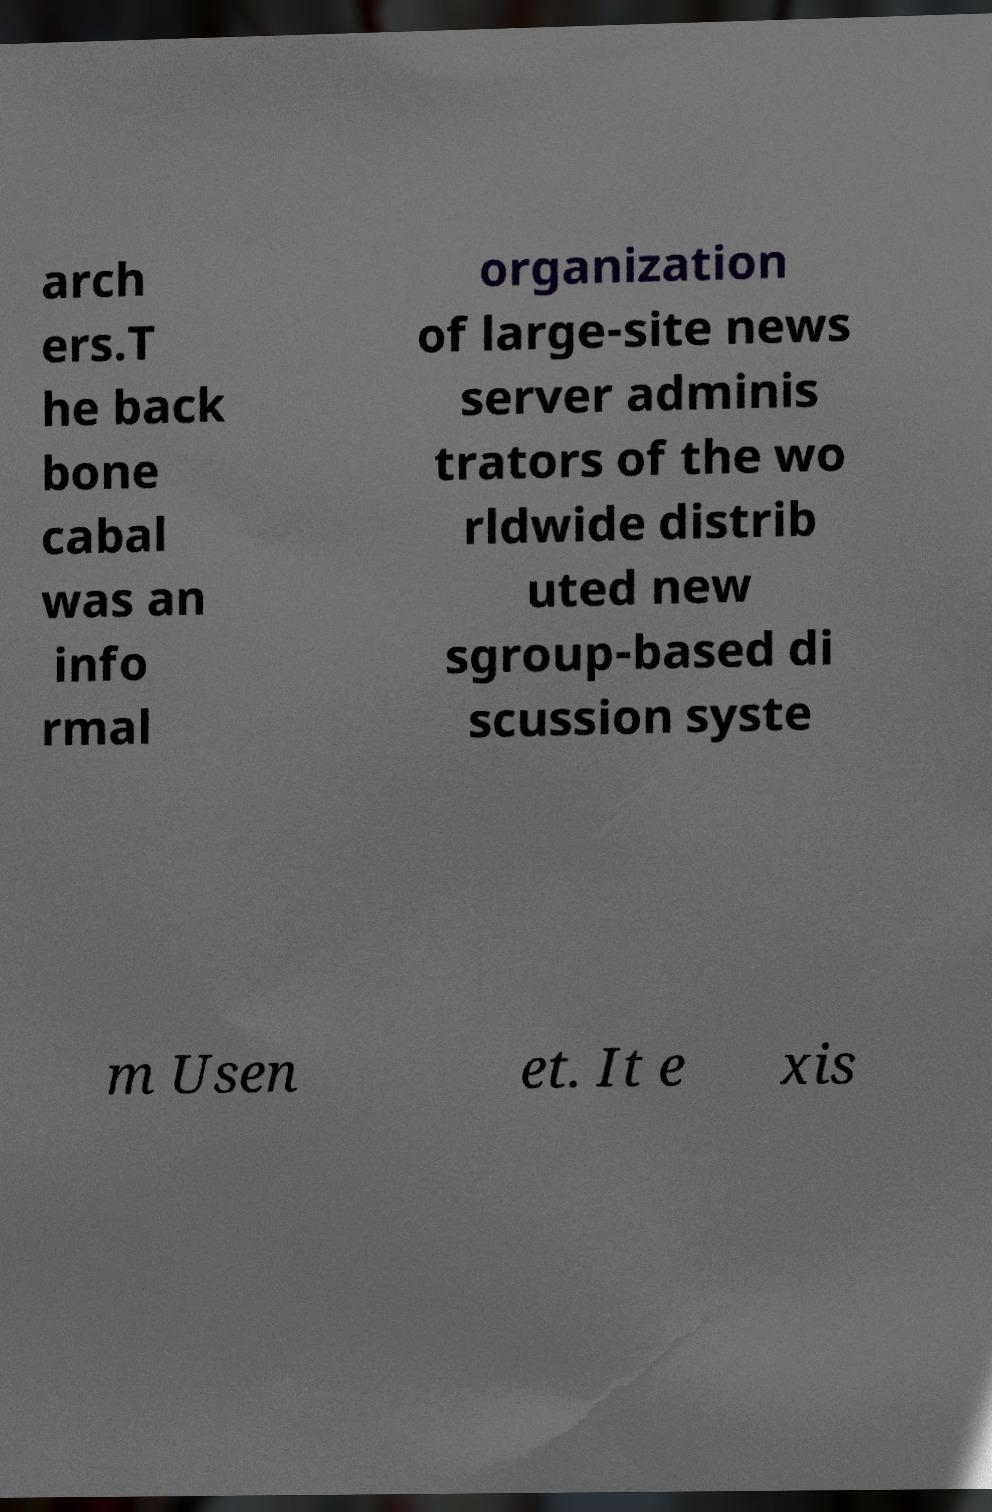For documentation purposes, I need the text within this image transcribed. Could you provide that? arch ers.T he back bone cabal was an info rmal organization of large-site news server adminis trators of the wo rldwide distrib uted new sgroup-based di scussion syste m Usen et. It e xis 